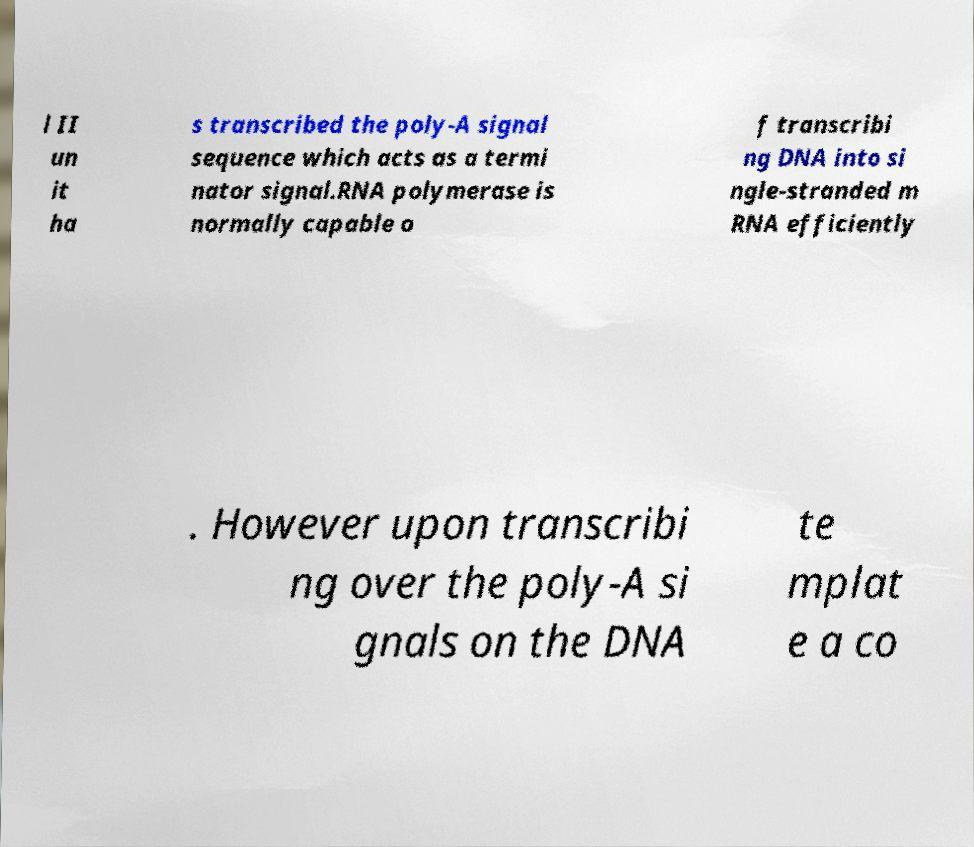Please read and relay the text visible in this image. What does it say? l II un it ha s transcribed the poly-A signal sequence which acts as a termi nator signal.RNA polymerase is normally capable o f transcribi ng DNA into si ngle-stranded m RNA efficiently . However upon transcribi ng over the poly-A si gnals on the DNA te mplat e a co 